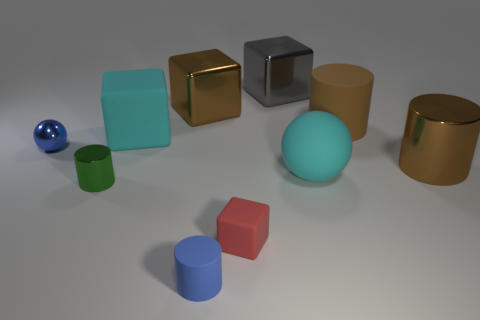Do the big shiny cylinder and the large rubber cylinder have the same color?
Make the answer very short. Yes. Do the matte cylinder that is to the right of the small red block and the big metal cylinder have the same color?
Give a very brief answer. Yes. There is a metal cylinder that is to the right of the brown rubber cylinder; does it have the same color as the rubber cylinder that is behind the large metallic cylinder?
Keep it short and to the point. Yes. What size is the matte object that is the same color as the shiny sphere?
Your answer should be compact. Small. What is the material of the object that is the same color as the large rubber sphere?
Your response must be concise. Rubber. Are there more large matte objects that are behind the cyan rubber block than cyan cylinders?
Keep it short and to the point. Yes. There is a brown metal object behind the cyan thing that is behind the large brown cylinder right of the big matte cylinder; what shape is it?
Offer a terse response. Cube. There is a tiny blue object that is behind the tiny red block; does it have the same shape as the brown metal thing to the left of the large gray metallic thing?
Ensure brevity in your answer.  No. How many cubes are brown things or large brown shiny objects?
Give a very brief answer. 1. Does the big cyan cube have the same material as the red object?
Offer a terse response. Yes. 